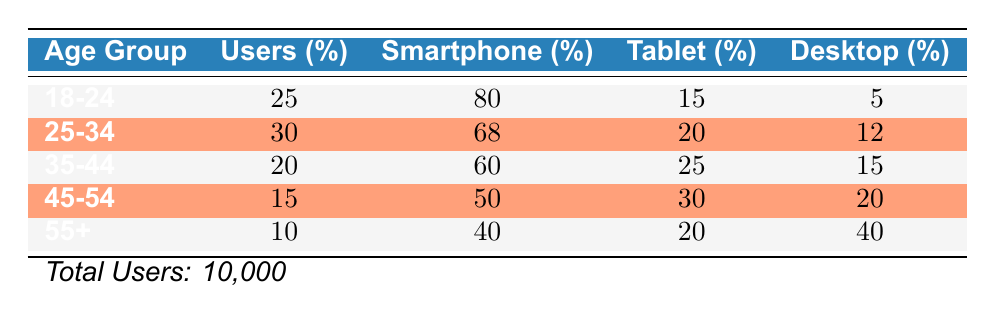What percentage of users are aged 25-34? Referring to the table, the percentage of users in the age group 25-34 is explicitly stated, which is 30%.
Answer: 30% Which age group has the highest percentage of smartphone users? By examining the data, the age group 18-24 has the highest percentage of smartphone users at 80%.
Answer: 18-24 What is the total percentage of users who access the application via desktop? To find the total percentage, sum the desktop percentages across all age groups: 5 + 12 + 15 + 20 + 40 = 92.
Answer: 92% Is it true that more users aged 45-54 prefer tablets over smartphones? Checking the percentages, users aged 45-54 are 30% tablet users and 50% smartphone users. Since 30 is less than 50, the statement is false.
Answer: No What is the average percentage of users accessing the application via tablet across all age groups? To compute the average, sum the tablet percentages (15 + 20 + 25 + 30 + 20 = 110) and divide by the number of age groups (5), resulting in an average of 110/5 = 22%.
Answer: 22% Which age group has the lowest percentage of users accessing the application? The lowest percentage in the table is for users aged 55+, who comprise 10% of all users.
Answer: 55+ What is the difference between the percentage of smartphone users in the age group 25-34 and that in the age group 35-44? Subtract the smartphone percentage of age group 35-44 (60%) from that of age group 25-34 (68%): 68 - 60 = 8%.
Answer: 8% Do users aged 35-44 have more access via tablet than users aged 55+? For the age group 35-44, the percentage of tablet users is 25%, while for 55+, it is only 20%. Thus, the statement is true.
Answer: Yes 